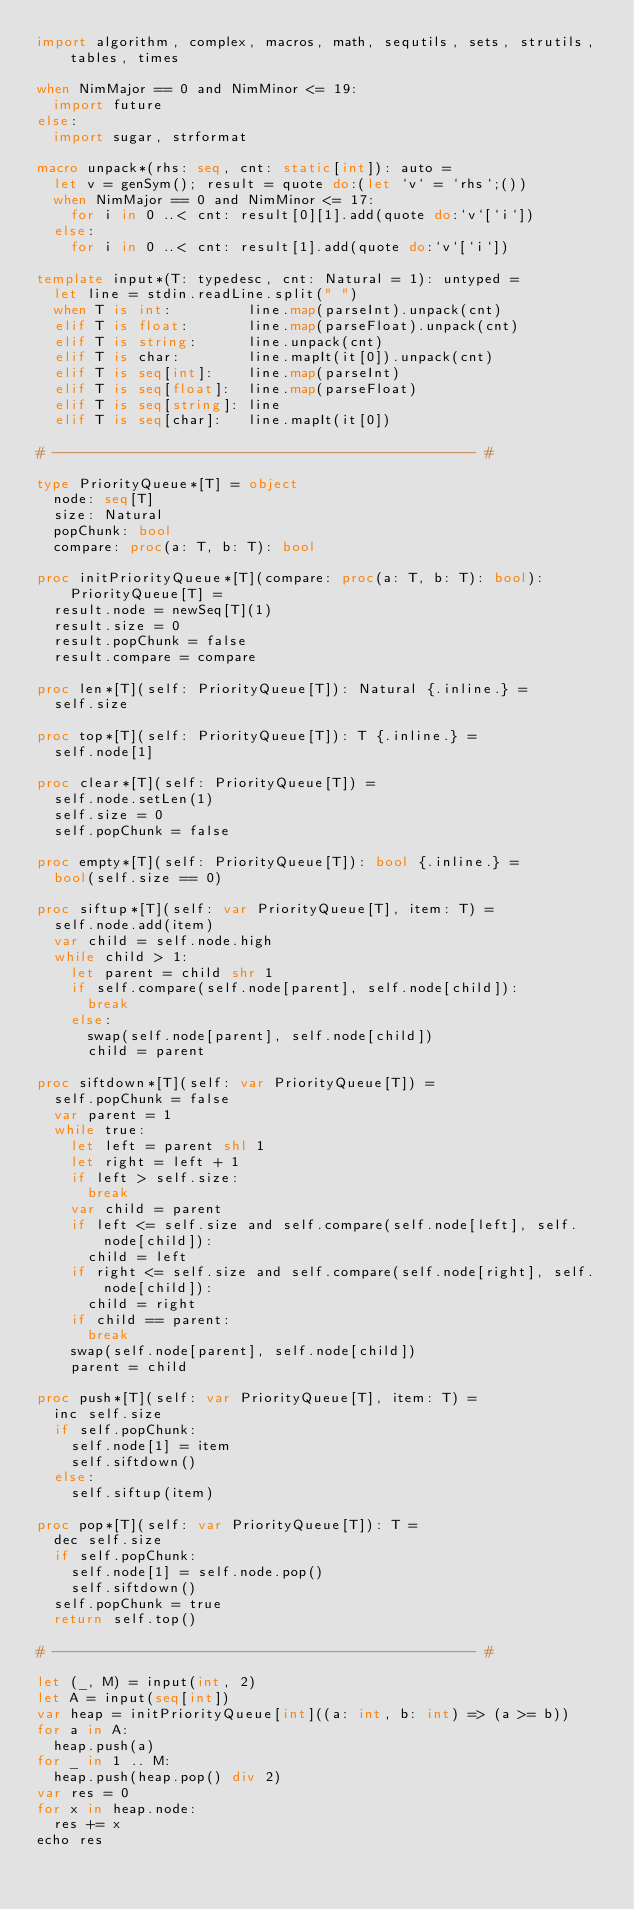Convert code to text. <code><loc_0><loc_0><loc_500><loc_500><_Nim_>import algorithm, complex, macros, math, sequtils, sets, strutils, tables, times

when NimMajor == 0 and NimMinor <= 19:
  import future
else:
  import sugar, strformat

macro unpack*(rhs: seq, cnt: static[int]): auto =
  let v = genSym(); result = quote do:(let `v` = `rhs`;())
  when NimMajor == 0 and NimMinor <= 17:
    for i in 0 ..< cnt: result[0][1].add(quote do:`v`[`i`])
  else:
    for i in 0 ..< cnt: result[1].add(quote do:`v`[`i`])

template input*(T: typedesc, cnt: Natural = 1): untyped =
  let line = stdin.readLine.split(" ")
  when T is int:         line.map(parseInt).unpack(cnt)
  elif T is float:       line.map(parseFloat).unpack(cnt)
  elif T is string:      line.unpack(cnt)
  elif T is char:        line.mapIt(it[0]).unpack(cnt)
  elif T is seq[int]:    line.map(parseInt)
  elif T is seq[float]:  line.map(parseFloat)
  elif T is seq[string]: line
  elif T is seq[char]:   line.mapIt(it[0])

# -------------------------------------------------- #

type PriorityQueue*[T] = object
  node: seq[T]
  size: Natural
  popChunk: bool
  compare: proc(a: T, b: T): bool

proc initPriorityQueue*[T](compare: proc(a: T, b: T): bool): PriorityQueue[T] =
  result.node = newSeq[T](1)
  result.size = 0
  result.popChunk = false
  result.compare = compare

proc len*[T](self: PriorityQueue[T]): Natural {.inline.} =
  self.size

proc top*[T](self: PriorityQueue[T]): T {.inline.} =
  self.node[1]

proc clear*[T](self: PriorityQueue[T]) =
  self.node.setLen(1)
  self.size = 0
  self.popChunk = false

proc empty*[T](self: PriorityQueue[T]): bool {.inline.} =
  bool(self.size == 0)

proc siftup*[T](self: var PriorityQueue[T], item: T) =
  self.node.add(item)
  var child = self.node.high
  while child > 1:
    let parent = child shr 1
    if self.compare(self.node[parent], self.node[child]):
      break
    else:
      swap(self.node[parent], self.node[child])
      child = parent

proc siftdown*[T](self: var PriorityQueue[T]) =
  self.popChunk = false
  var parent = 1
  while true:
    let left = parent shl 1
    let right = left + 1
    if left > self.size:
      break
    var child = parent
    if left <= self.size and self.compare(self.node[left], self.node[child]):
      child = left
    if right <= self.size and self.compare(self.node[right], self.node[child]):
      child = right
    if child == parent:
      break
    swap(self.node[parent], self.node[child])
    parent = child

proc push*[T](self: var PriorityQueue[T], item: T) =
  inc self.size
  if self.popChunk:
    self.node[1] = item
    self.siftdown()
  else:
    self.siftup(item)

proc pop*[T](self: var PriorityQueue[T]): T =
  dec self.size
  if self.popChunk:
    self.node[1] = self.node.pop()
    self.siftdown()
  self.popChunk = true
  return self.top()

# -------------------------------------------------- #

let (_, M) = input(int, 2)
let A = input(seq[int])
var heap = initPriorityQueue[int]((a: int, b: int) => (a >= b))
for a in A:
  heap.push(a)
for _ in 1 .. M:
  heap.push(heap.pop() div 2)
var res = 0
for x in heap.node:
  res += x
echo res</code> 